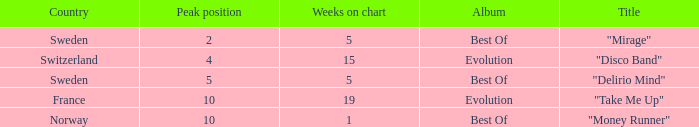What is the weeks on chart for the single from france? 19.0. 